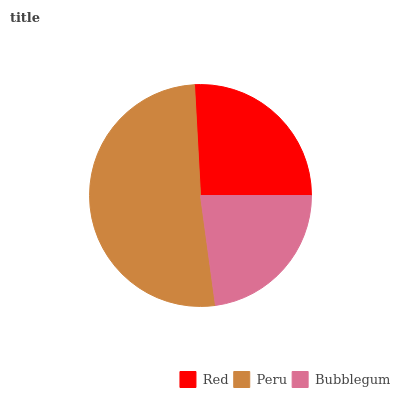Is Bubblegum the minimum?
Answer yes or no. Yes. Is Peru the maximum?
Answer yes or no. Yes. Is Peru the minimum?
Answer yes or no. No. Is Bubblegum the maximum?
Answer yes or no. No. Is Peru greater than Bubblegum?
Answer yes or no. Yes. Is Bubblegum less than Peru?
Answer yes or no. Yes. Is Bubblegum greater than Peru?
Answer yes or no. No. Is Peru less than Bubblegum?
Answer yes or no. No. Is Red the high median?
Answer yes or no. Yes. Is Red the low median?
Answer yes or no. Yes. Is Peru the high median?
Answer yes or no. No. Is Peru the low median?
Answer yes or no. No. 